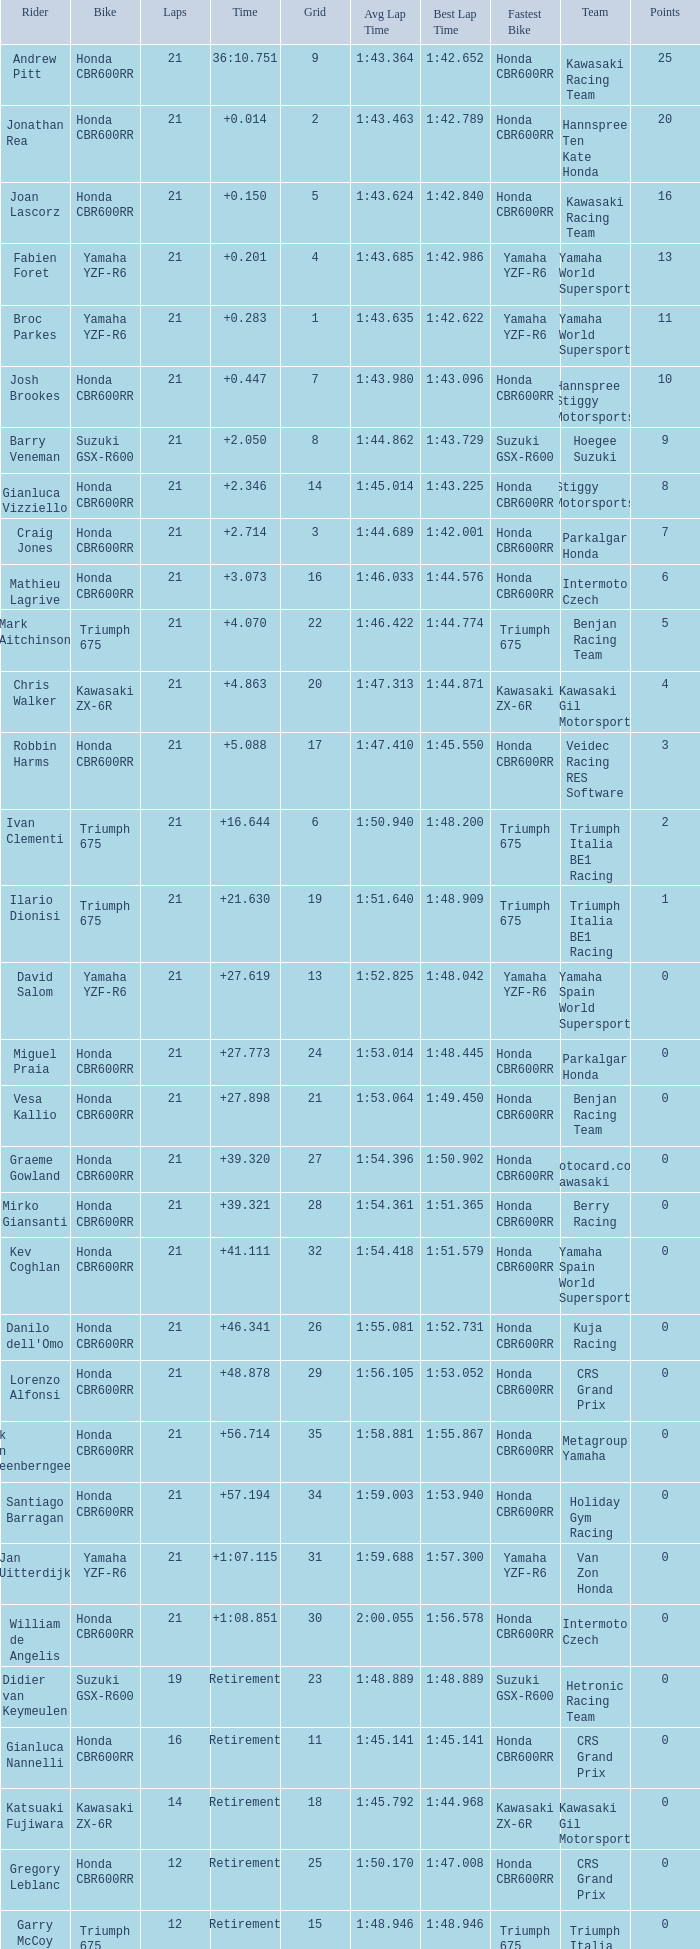What is the driver with the laps under 16, grid of 10, a bike of Yamaha YZF-R6, and ended with an accident? Massimo Roccoli. 